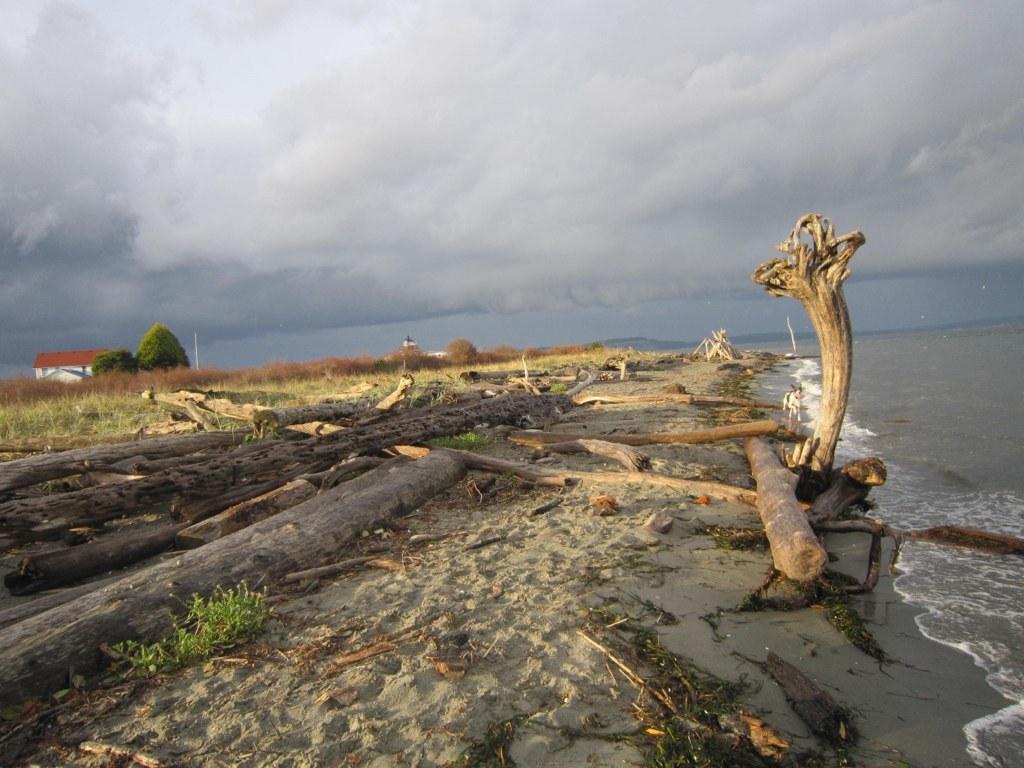How would you summarize this image in a sentence or two? In this image I can see the sea on the right side and in front of sea I can see few trunks , grass,house, trees, at the top I can see the sky. 